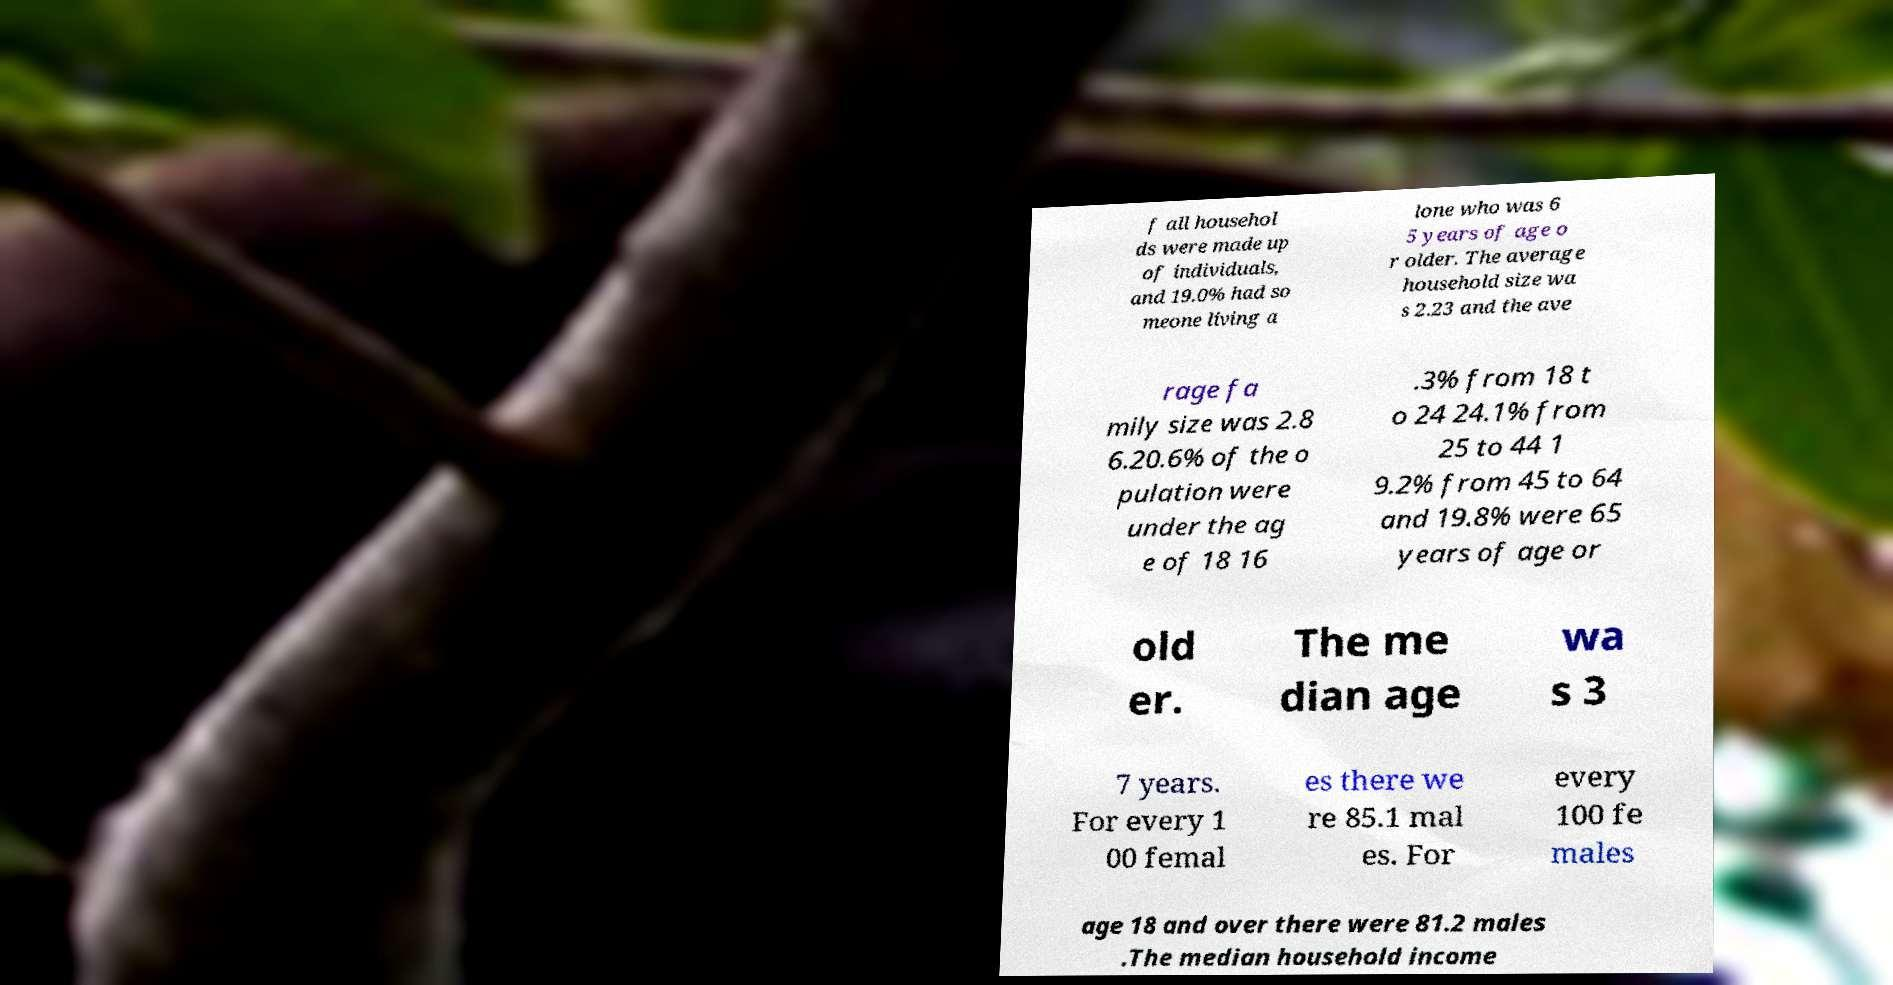Could you assist in decoding the text presented in this image and type it out clearly? f all househol ds were made up of individuals, and 19.0% had so meone living a lone who was 6 5 years of age o r older. The average household size wa s 2.23 and the ave rage fa mily size was 2.8 6.20.6% of the o pulation were under the ag e of 18 16 .3% from 18 t o 24 24.1% from 25 to 44 1 9.2% from 45 to 64 and 19.8% were 65 years of age or old er. The me dian age wa s 3 7 years. For every 1 00 femal es there we re 85.1 mal es. For every 100 fe males age 18 and over there were 81.2 males .The median household income 